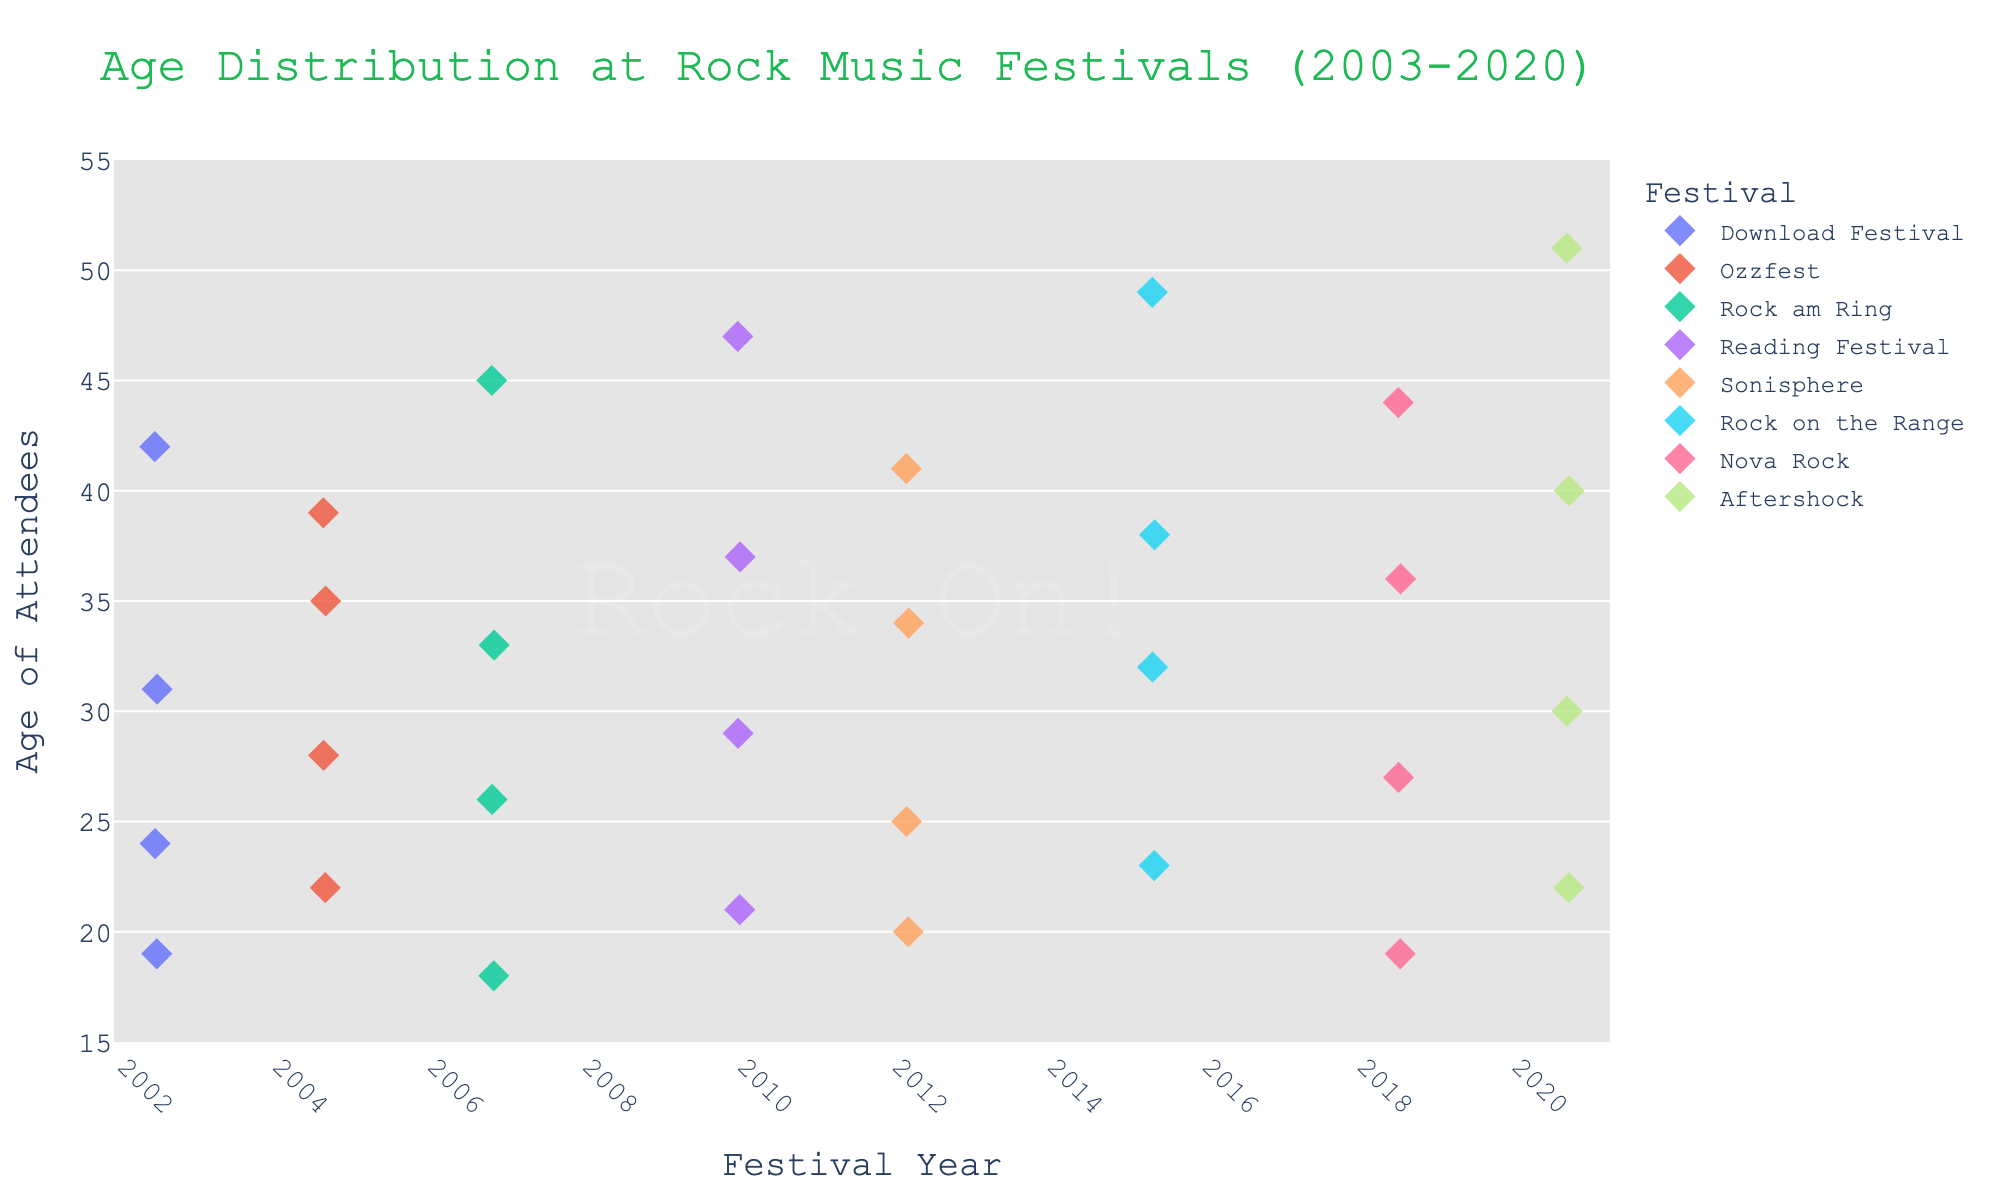What is the age range of attendees in the year 2020? The attendees' ages in 2020 span from the youngest, who is 22 years old, to the oldest, who is 51 years old.
Answer: 22 to 51 Which festival has the most data points? By counting the number of dots for each festival, we can see that each festival has the same number of data points, specifically 4.
Answer: All festivals have equal data points What is the average age of attendees at Rock on the Range in 2015? Sum the ages of attendees (23 + 32 + 38 + 49) to get 142, then divide by 4 (number of data points) to find the average: 142 / 4 = 35.5
Answer: 35.5 In which year was the youngest attendee recorded? The youngest attendee is 18 years old and they attended Rock am Ring in the year 2007.
Answer: 2007 How does the age distribution in 2003 compare to 2010? In 2003, attendee ages are 19, 24, 31, and 42. In 2010, they are 21, 29, 37, and 47. Generally, the 2010 cohort is slightly older than the 2003 cohort.
Answer: 2010 has older attendees on average Which festival in the given dataset has the oldest attendee and what is their age? The oldest attendee is 51 years old and they were at Aftershock in 2020.
Answer: Aftershock, 51 Identify the median age of attendees at Reading Festival in 2010. The ages are 21, 29, 37, and 47. After ordering, the median is the average of the two middle numbers: (29 + 37) / 2 = 33.
Answer: 33 What is the difference between the youngest and oldest attendees at the Nova Rock festival in 2018? The youngest attendee is 19 years old and the oldest is 44 years old. The difference is 44 - 19 = 25.
Answer: 25 Which festival had the youngest average age of attendees? Calculate the average age for all festivals. The festival with the lowest average will be the one with the youngest average age. After calculations, we find that Download Festival in 2003 has the youngest average.
Answer: Download Festival Which festival had a major variation in attendee ages and how can you tell from the figure? By observing the scatter of data points, Rock on the Range in 2015 has ages ranging from 23 to 49, showing a wide variation.
Answer: Rock on the Range 